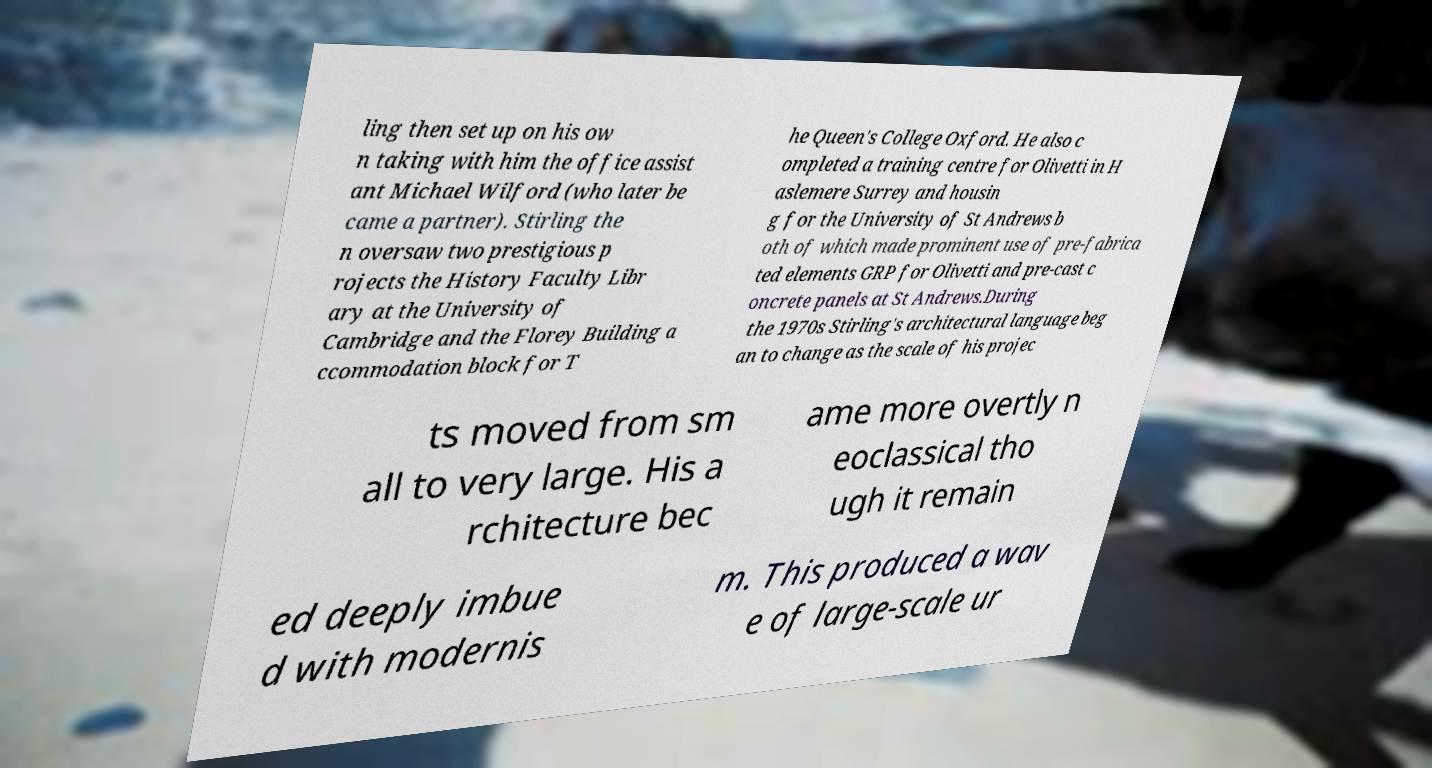For documentation purposes, I need the text within this image transcribed. Could you provide that? ling then set up on his ow n taking with him the office assist ant Michael Wilford (who later be came a partner). Stirling the n oversaw two prestigious p rojects the History Faculty Libr ary at the University of Cambridge and the Florey Building a ccommodation block for T he Queen's College Oxford. He also c ompleted a training centre for Olivetti in H aslemere Surrey and housin g for the University of St Andrews b oth of which made prominent use of pre-fabrica ted elements GRP for Olivetti and pre-cast c oncrete panels at St Andrews.During the 1970s Stirling's architectural language beg an to change as the scale of his projec ts moved from sm all to very large. His a rchitecture bec ame more overtly n eoclassical tho ugh it remain ed deeply imbue d with modernis m. This produced a wav e of large-scale ur 